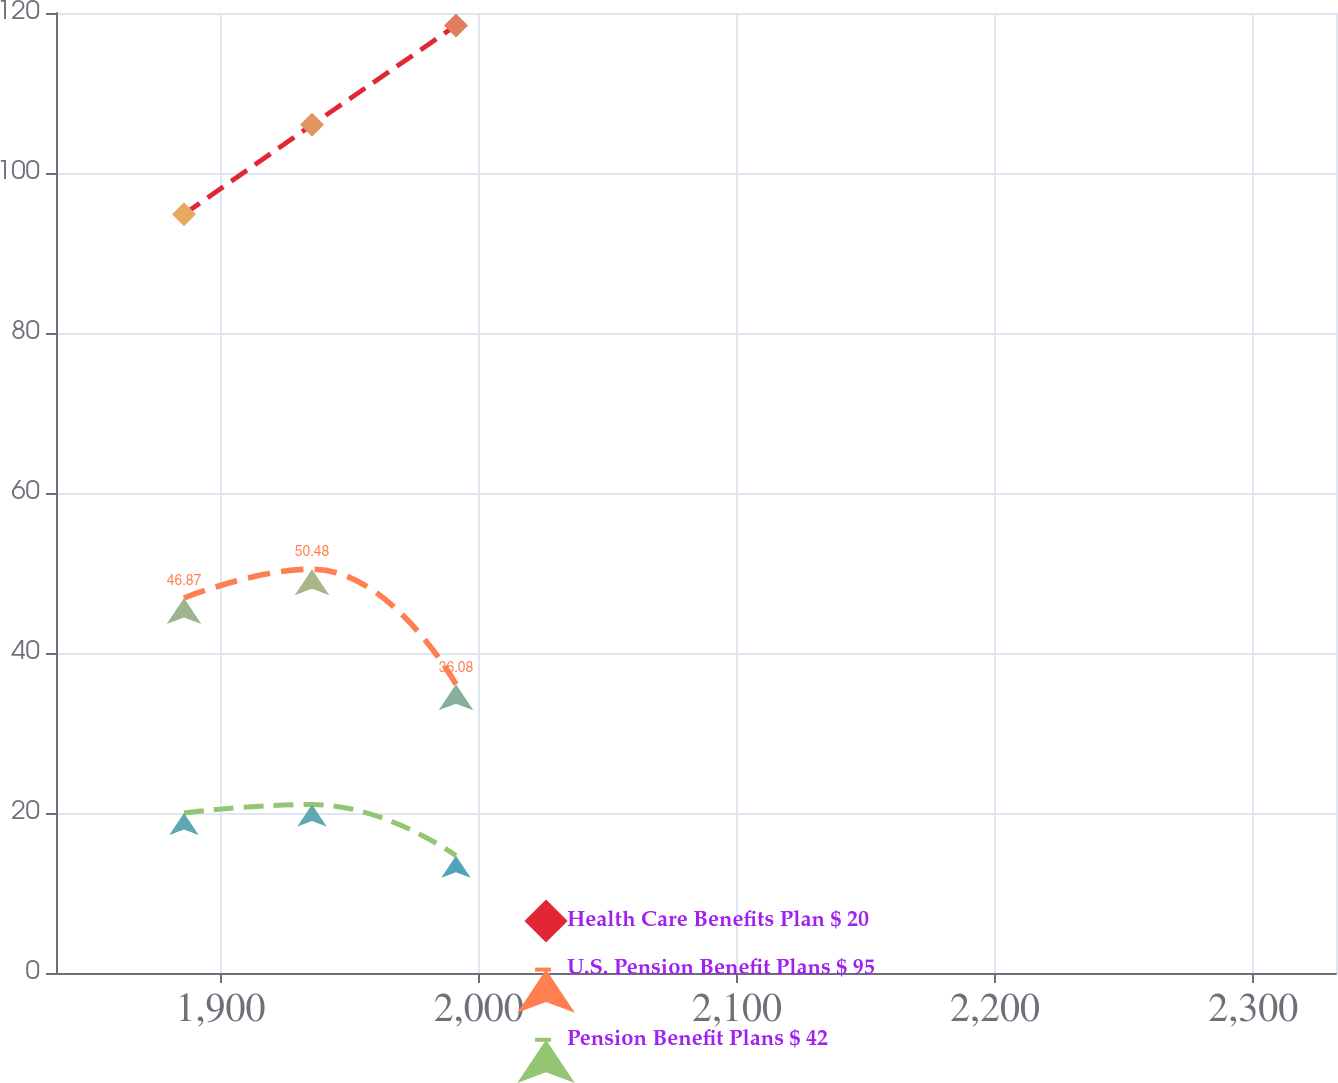Convert chart. <chart><loc_0><loc_0><loc_500><loc_500><line_chart><ecel><fcel>Health Care Benefits Plan $ 20<fcel>U.S. Pension Benefit Plans $ 95<fcel>Pension Benefit Plans $ 42<nl><fcel>1885.86<fcel>94.84<fcel>46.87<fcel>20<nl><fcel>1935.44<fcel>106.02<fcel>50.48<fcel>21.06<nl><fcel>1991.2<fcel>118.44<fcel>36.08<fcel>14.65<nl><fcel>2381.62<fcel>143.63<fcel>45.43<fcel>13.94<nl></chart> 